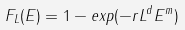<formula> <loc_0><loc_0><loc_500><loc_500>F _ { L } ( E ) = 1 - e x p ( - r L ^ { d } E ^ { m } )</formula> 